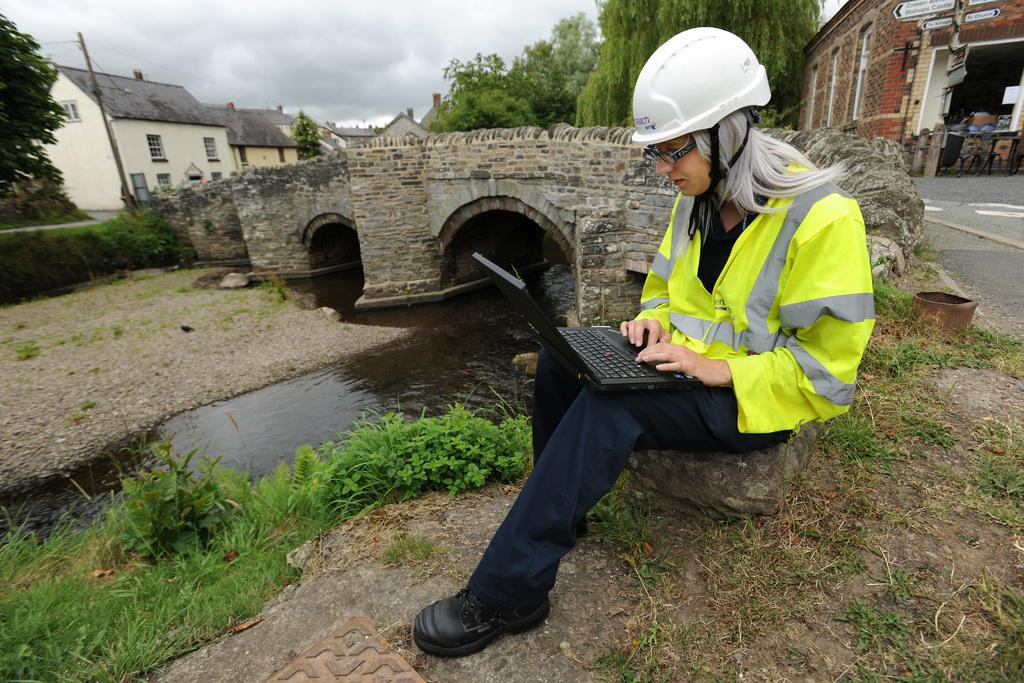What is the lady in the image doing? The lady in the image is working on a laptop. What can be seen in the image besides the lady and her laptop? Water, grass, houses, trees, and clouds in the sky are visible in the image. Can you describe the background of the image? The background of the image includes houses, trees, and clouds in the sky. What type of natural environment is visible in the image? The natural environment in the image includes water, grass, and trees. What type of stew is being prepared in the image? There is no stew present in the image; it features a lady working on a laptop in a natural environment. Can you describe the cat in the image? There is no cat present in the image. 